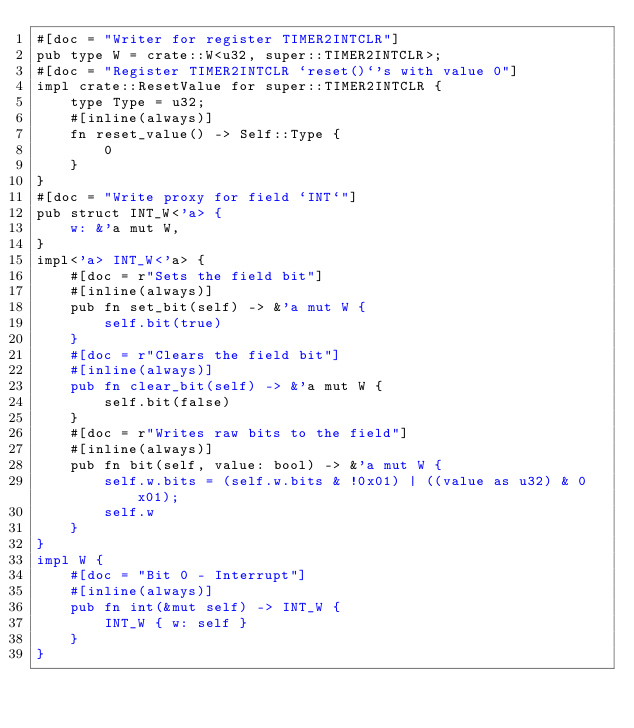<code> <loc_0><loc_0><loc_500><loc_500><_Rust_>#[doc = "Writer for register TIMER2INTCLR"]
pub type W = crate::W<u32, super::TIMER2INTCLR>;
#[doc = "Register TIMER2INTCLR `reset()`'s with value 0"]
impl crate::ResetValue for super::TIMER2INTCLR {
    type Type = u32;
    #[inline(always)]
    fn reset_value() -> Self::Type {
        0
    }
}
#[doc = "Write proxy for field `INT`"]
pub struct INT_W<'a> {
    w: &'a mut W,
}
impl<'a> INT_W<'a> {
    #[doc = r"Sets the field bit"]
    #[inline(always)]
    pub fn set_bit(self) -> &'a mut W {
        self.bit(true)
    }
    #[doc = r"Clears the field bit"]
    #[inline(always)]
    pub fn clear_bit(self) -> &'a mut W {
        self.bit(false)
    }
    #[doc = r"Writes raw bits to the field"]
    #[inline(always)]
    pub fn bit(self, value: bool) -> &'a mut W {
        self.w.bits = (self.w.bits & !0x01) | ((value as u32) & 0x01);
        self.w
    }
}
impl W {
    #[doc = "Bit 0 - Interrupt"]
    #[inline(always)]
    pub fn int(&mut self) -> INT_W {
        INT_W { w: self }
    }
}
</code> 